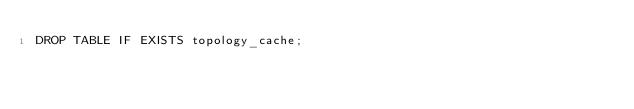<code> <loc_0><loc_0><loc_500><loc_500><_SQL_>DROP TABLE IF EXISTS topology_cache;
</code> 